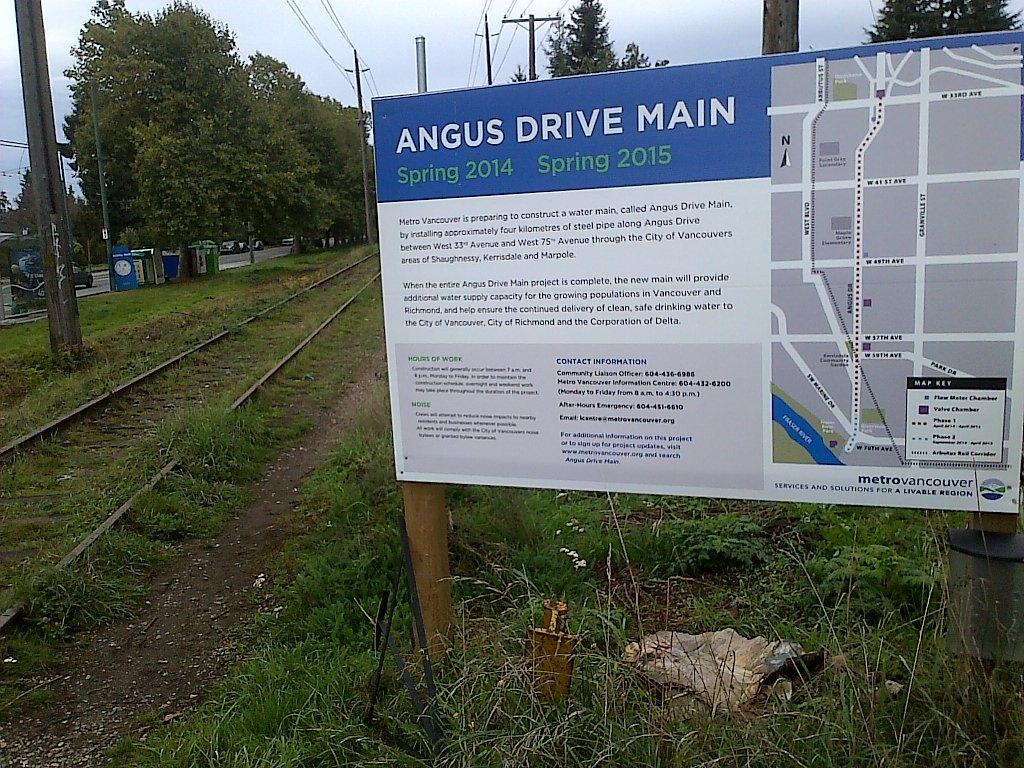What is hanging in the image? There is a banner in the image. What can be seen behind the banner? Trees, poles, and electric wires are visible behind the banner. What is located on the left side of the image? There is a railway track on the left side of the image. What type of vegetation covers the land in the image? The land is covered with grass. What type of toothbrush is hanging from the banner in the image? A: There is no toothbrush present in the image. What vegetables are growing on the railway track in the image? There are no vegetables growing on the railway track in the image. 